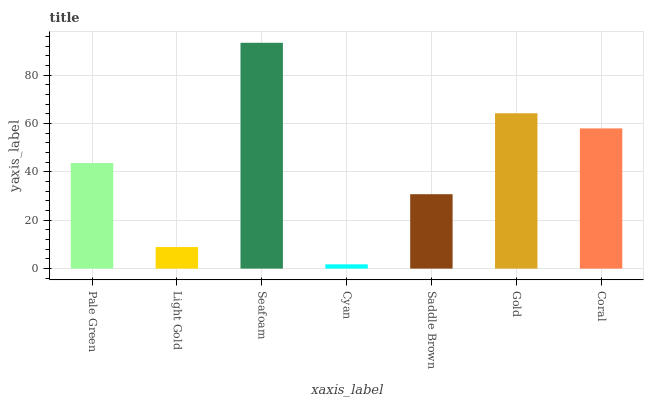Is Cyan the minimum?
Answer yes or no. Yes. Is Seafoam the maximum?
Answer yes or no. Yes. Is Light Gold the minimum?
Answer yes or no. No. Is Light Gold the maximum?
Answer yes or no. No. Is Pale Green greater than Light Gold?
Answer yes or no. Yes. Is Light Gold less than Pale Green?
Answer yes or no. Yes. Is Light Gold greater than Pale Green?
Answer yes or no. No. Is Pale Green less than Light Gold?
Answer yes or no. No. Is Pale Green the high median?
Answer yes or no. Yes. Is Pale Green the low median?
Answer yes or no. Yes. Is Cyan the high median?
Answer yes or no. No. Is Seafoam the low median?
Answer yes or no. No. 